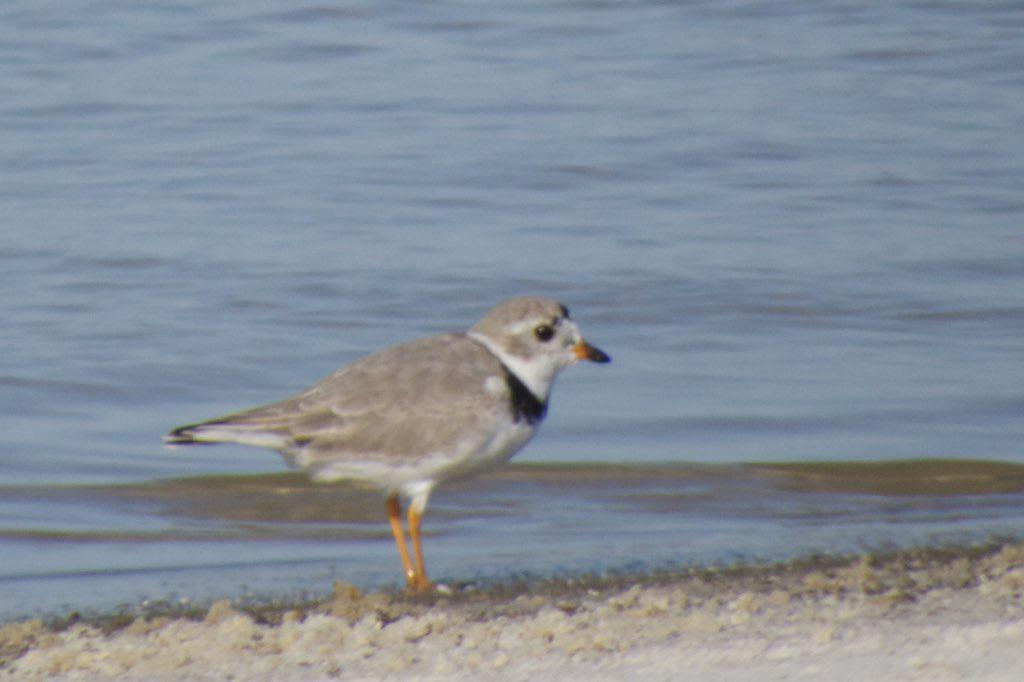What type of animal can be seen in the image? There is a bird in the image. What is the primary surface visible in the image? There is a ground at the bottom of the image. What natural element can be seen in the background of the image? There is water visible in the background of the image. What type of books does the government use to control the bird in the image? There is no mention of books or government control in the image; it simply features a bird and a ground with water in the background. 